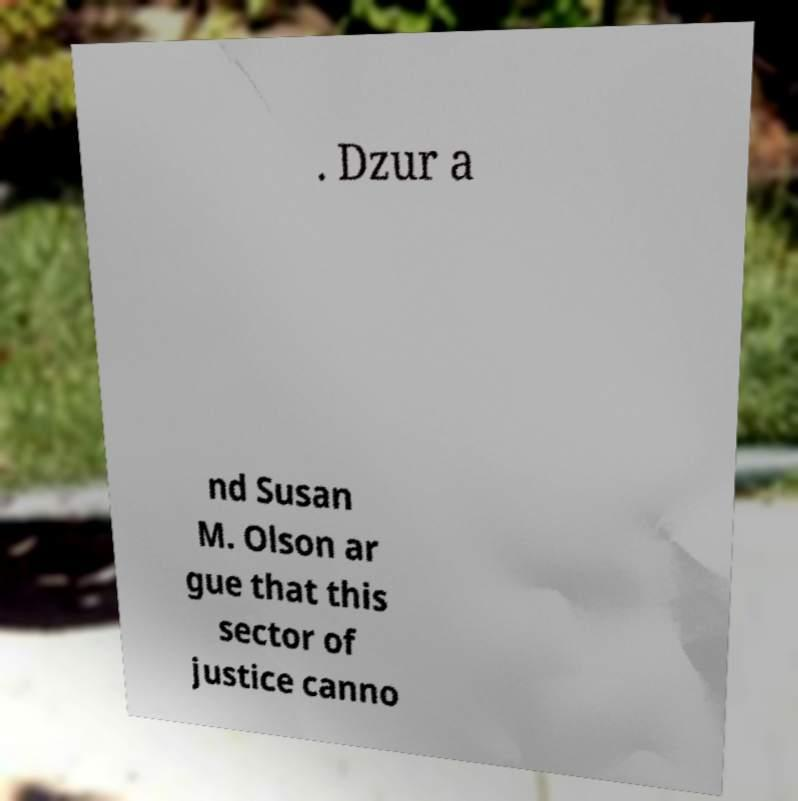Can you read and provide the text displayed in the image?This photo seems to have some interesting text. Can you extract and type it out for me? . Dzur a nd Susan M. Olson ar gue that this sector of justice canno 